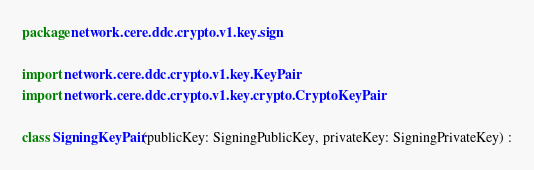Convert code to text. <code><loc_0><loc_0><loc_500><loc_500><_Kotlin_>package network.cere.ddc.crypto.v1.key.sign

import network.cere.ddc.crypto.v1.key.KeyPair
import network.cere.ddc.crypto.v1.key.crypto.CryptoKeyPair

class SigningKeyPair(publicKey: SigningPublicKey, privateKey: SigningPrivateKey) :</code> 